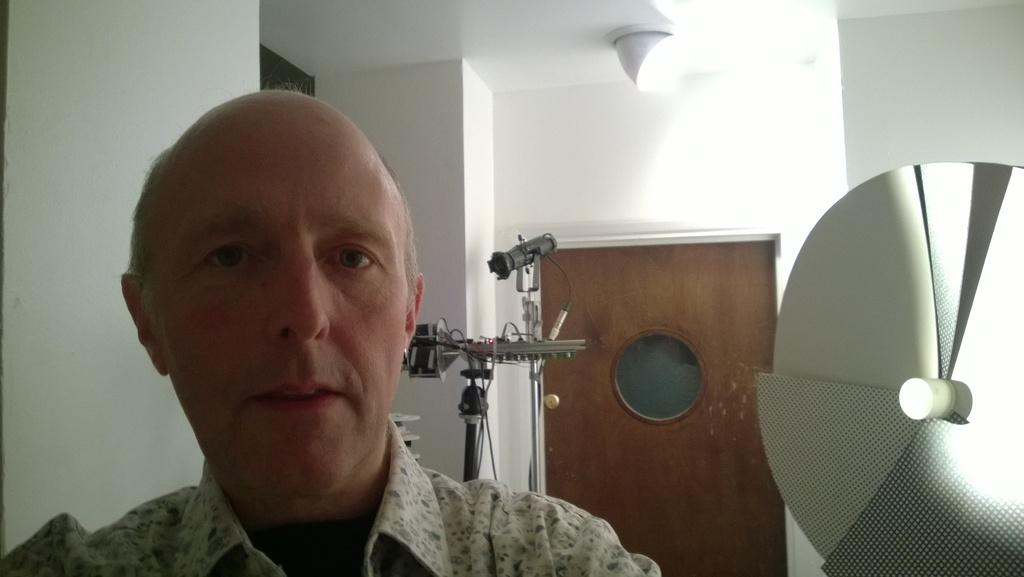Who is present in the image? There is a man in the image. What can be seen besides the man? There is equipment in the image. Can you describe the door in the image? There is a door in the image. What color is the wall in the image? The wall in the image is white. What type of lighting is present in the image? There is a light on the ceiling in the image. How many roses are on the man's shirt in the image? There are no roses present on the man's shirt in the image. What emotion does the man feel as he looks at the crayon in the image? There is no crayon present in the image, and therefore no emotion related to it can be determined. 